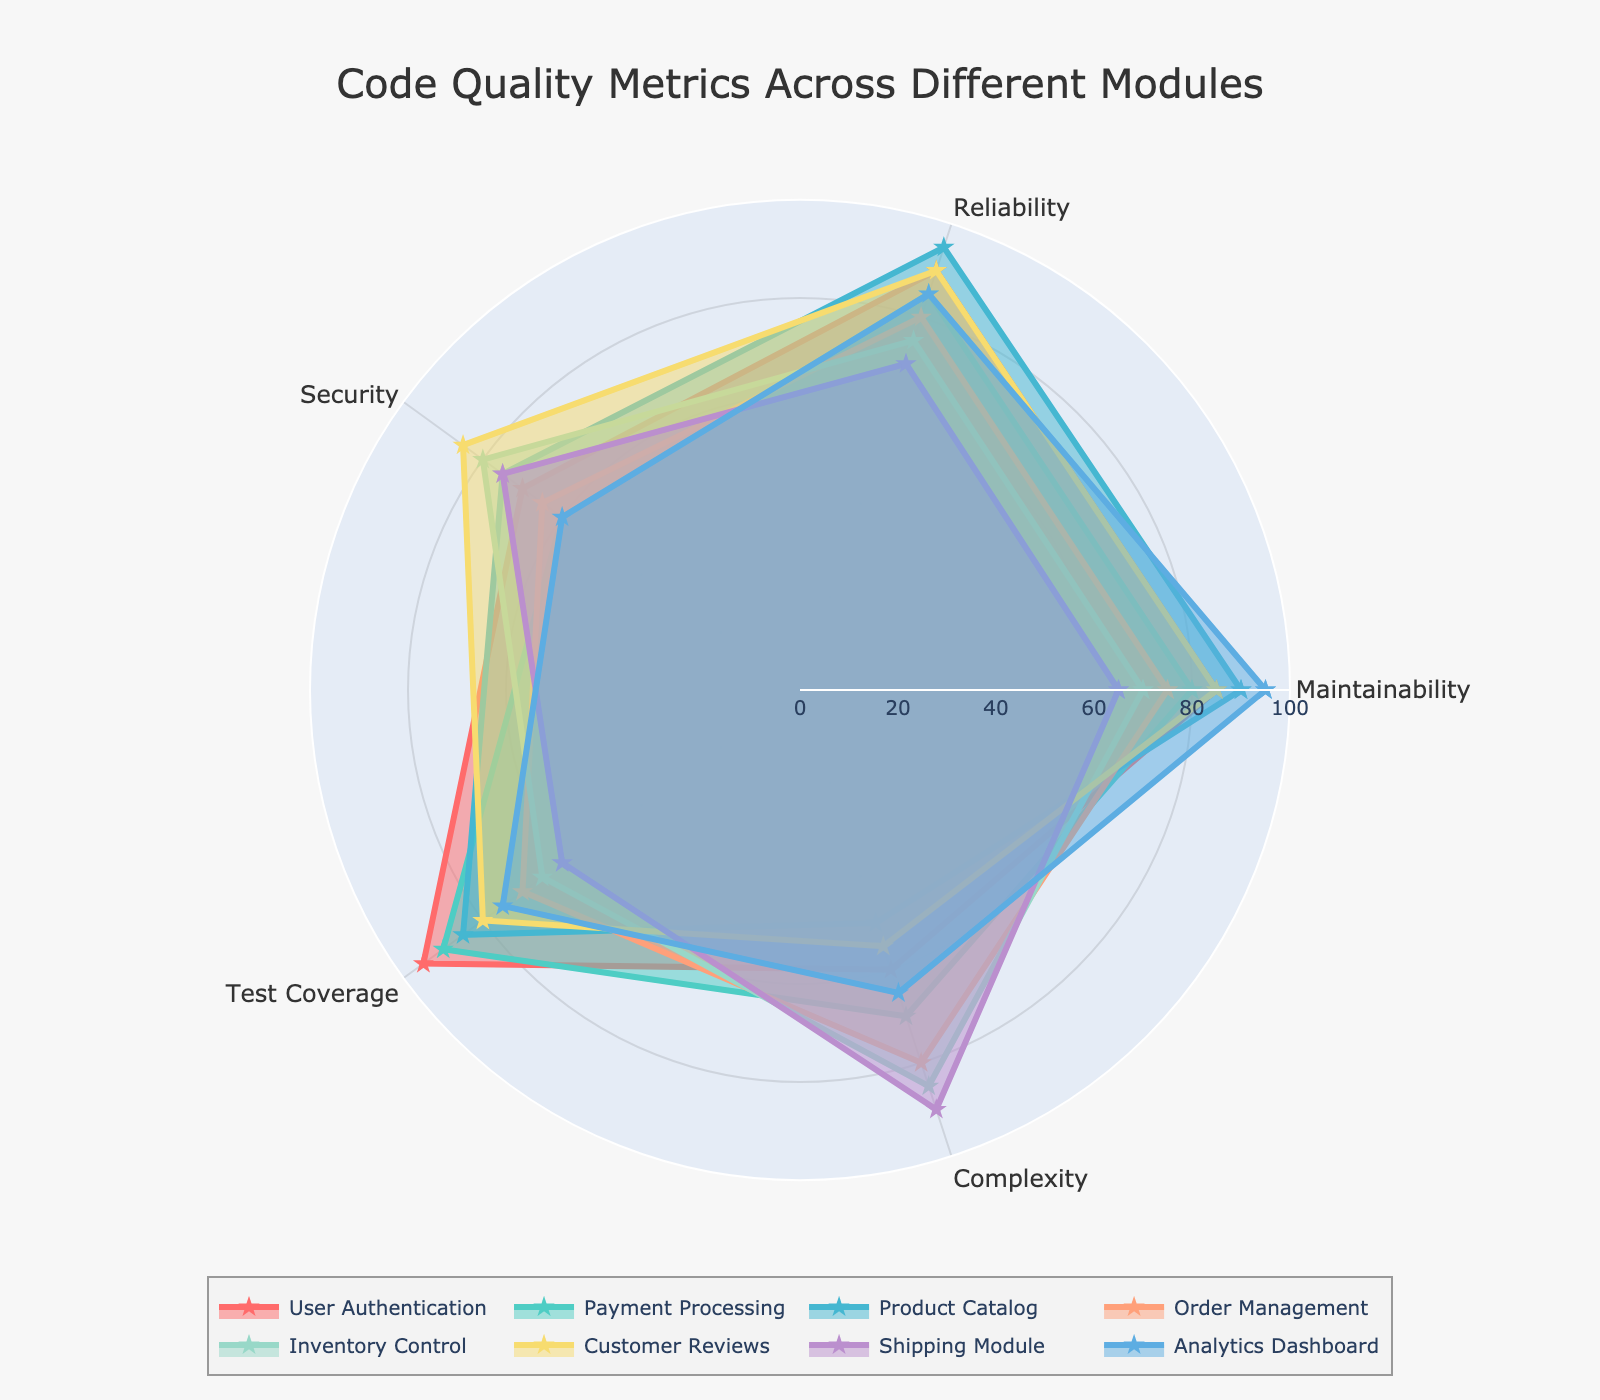What is the title of the radar chart? The title is displayed at the top center of the radar chart. It usually provides a summary of what the chart is about.
Answer: Code Quality Metrics Across Different Modules Which module has the highest maintainability score? By looking at the 'Maintainability' axis, you can identify the module with the highest score in that category.
Answer: Analytics Dashboard Between 'User Authentication' and 'Customer Reviews,' which module has higher test coverage? Compare the 'Test Coverage' scores for both modules on the radar chart.
Answer: User Authentication What's the average reliability score across all modules? Sum the reliability scores (90+85+95+80+75+90+70+85) and divide by the number of modules (8).
Answer: 83.75 Which module exhibits the highest complexity? By looking at the 'Complexity' axis, identify the module that has the highest value in that dimension.
Answer: Shipping Module What is the difference in the security score between 'Payment Processing' and 'Inventory Control'? Subtract the security score of 'Payment Processing' from 'Inventory Control' (80-60).
Answer: 20 Among all modules, which one has the lowest test coverage? By comparing the test coverage values, find the module with the lowest score.
Answer: Shipping Module Which module has the best overall code quality, based on an average of all five metrics? Calculate the average for each module and compare; Analytics Dashboard (76), User Authentication (80), Payment Processing (77), Product Catalog (79), Order Management (74), Inventory Control (75), Customer Reviews (79), Shipping Module (72).
Answer: User Authentication If the goal is to reduce complexity, which module should be the first to focus on? Identify the module with the highest complexity score by examining the 'Complexity' axis.
Answer: Shipping Module 